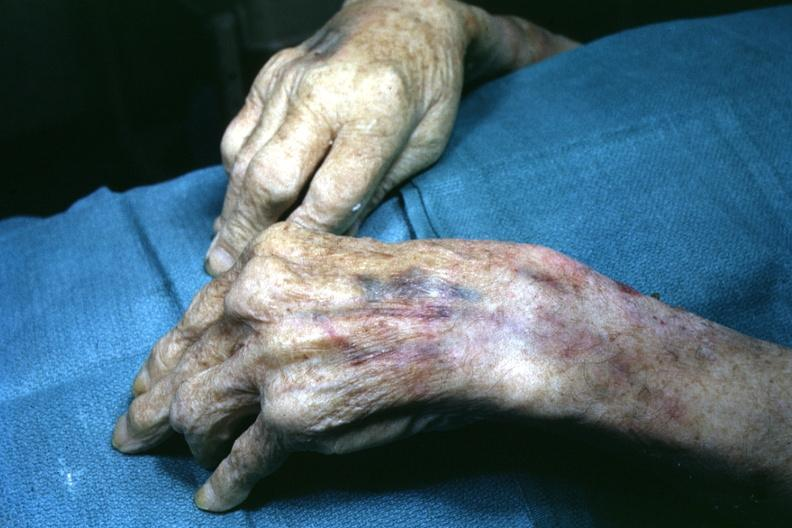re cells present?
Answer the question using a single word or phrase. No 